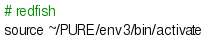<code> <loc_0><loc_0><loc_500><loc_500><_Bash_># redfish
source ~/PURE/env3/bin/activate</code> 